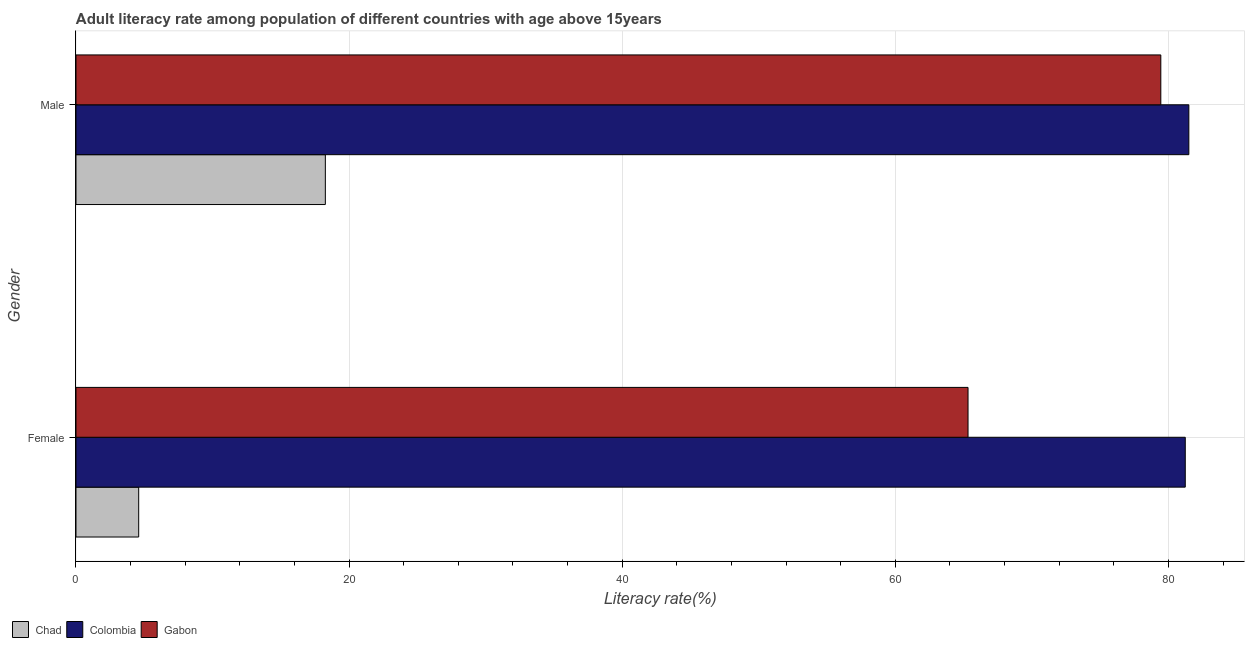How many different coloured bars are there?
Ensure brevity in your answer.  3. How many groups of bars are there?
Keep it short and to the point. 2. Are the number of bars on each tick of the Y-axis equal?
Provide a short and direct response. Yes. How many bars are there on the 2nd tick from the top?
Ensure brevity in your answer.  3. How many bars are there on the 1st tick from the bottom?
Your response must be concise. 3. What is the male adult literacy rate in Colombia?
Your answer should be compact. 81.5. Across all countries, what is the maximum male adult literacy rate?
Give a very brief answer. 81.5. Across all countries, what is the minimum male adult literacy rate?
Provide a short and direct response. 18.26. In which country was the male adult literacy rate minimum?
Your answer should be compact. Chad. What is the total male adult literacy rate in the graph?
Offer a very short reply. 179.2. What is the difference between the male adult literacy rate in Chad and that in Gabon?
Make the answer very short. -61.18. What is the difference between the female adult literacy rate in Colombia and the male adult literacy rate in Gabon?
Your response must be concise. 1.79. What is the average female adult literacy rate per country?
Provide a succinct answer. 50.38. What is the difference between the male adult literacy rate and female adult literacy rate in Colombia?
Your response must be concise. 0.26. In how many countries, is the male adult literacy rate greater than 8 %?
Make the answer very short. 3. What is the ratio of the male adult literacy rate in Gabon to that in Chad?
Provide a short and direct response. 4.35. Is the male adult literacy rate in Gabon less than that in Chad?
Provide a succinct answer. No. What does the 2nd bar from the top in Female represents?
Provide a succinct answer. Colombia. What does the 2nd bar from the bottom in Male represents?
Your answer should be very brief. Colombia. How many bars are there?
Ensure brevity in your answer.  6. What is the difference between two consecutive major ticks on the X-axis?
Your answer should be very brief. 20. Does the graph contain any zero values?
Provide a succinct answer. No. Where does the legend appear in the graph?
Your response must be concise. Bottom left. How many legend labels are there?
Provide a short and direct response. 3. What is the title of the graph?
Your answer should be very brief. Adult literacy rate among population of different countries with age above 15years. What is the label or title of the X-axis?
Offer a terse response. Literacy rate(%). What is the label or title of the Y-axis?
Make the answer very short. Gender. What is the Literacy rate(%) of Chad in Female?
Offer a very short reply. 4.59. What is the Literacy rate(%) of Colombia in Female?
Keep it short and to the point. 81.24. What is the Literacy rate(%) of Gabon in Female?
Your answer should be compact. 65.33. What is the Literacy rate(%) of Chad in Male?
Provide a succinct answer. 18.26. What is the Literacy rate(%) in Colombia in Male?
Make the answer very short. 81.5. What is the Literacy rate(%) in Gabon in Male?
Offer a terse response. 79.44. Across all Gender, what is the maximum Literacy rate(%) in Chad?
Offer a terse response. 18.26. Across all Gender, what is the maximum Literacy rate(%) of Colombia?
Keep it short and to the point. 81.5. Across all Gender, what is the maximum Literacy rate(%) in Gabon?
Make the answer very short. 79.44. Across all Gender, what is the minimum Literacy rate(%) in Chad?
Make the answer very short. 4.59. Across all Gender, what is the minimum Literacy rate(%) of Colombia?
Ensure brevity in your answer.  81.24. Across all Gender, what is the minimum Literacy rate(%) of Gabon?
Give a very brief answer. 65.33. What is the total Literacy rate(%) of Chad in the graph?
Give a very brief answer. 22.85. What is the total Literacy rate(%) of Colombia in the graph?
Your answer should be very brief. 162.73. What is the total Literacy rate(%) of Gabon in the graph?
Your response must be concise. 144.77. What is the difference between the Literacy rate(%) of Chad in Female and that in Male?
Give a very brief answer. -13.67. What is the difference between the Literacy rate(%) of Colombia in Female and that in Male?
Your response must be concise. -0.26. What is the difference between the Literacy rate(%) of Gabon in Female and that in Male?
Your response must be concise. -14.12. What is the difference between the Literacy rate(%) in Chad in Female and the Literacy rate(%) in Colombia in Male?
Provide a succinct answer. -76.91. What is the difference between the Literacy rate(%) in Chad in Female and the Literacy rate(%) in Gabon in Male?
Provide a succinct answer. -74.85. What is the difference between the Literacy rate(%) in Colombia in Female and the Literacy rate(%) in Gabon in Male?
Keep it short and to the point. 1.79. What is the average Literacy rate(%) of Chad per Gender?
Ensure brevity in your answer.  11.43. What is the average Literacy rate(%) of Colombia per Gender?
Keep it short and to the point. 81.37. What is the average Literacy rate(%) in Gabon per Gender?
Your answer should be compact. 72.39. What is the difference between the Literacy rate(%) in Chad and Literacy rate(%) in Colombia in Female?
Your answer should be compact. -76.64. What is the difference between the Literacy rate(%) of Chad and Literacy rate(%) of Gabon in Female?
Provide a succinct answer. -60.73. What is the difference between the Literacy rate(%) in Colombia and Literacy rate(%) in Gabon in Female?
Provide a short and direct response. 15.91. What is the difference between the Literacy rate(%) of Chad and Literacy rate(%) of Colombia in Male?
Offer a very short reply. -63.24. What is the difference between the Literacy rate(%) in Chad and Literacy rate(%) in Gabon in Male?
Provide a short and direct response. -61.18. What is the difference between the Literacy rate(%) of Colombia and Literacy rate(%) of Gabon in Male?
Your answer should be very brief. 2.05. What is the ratio of the Literacy rate(%) of Chad in Female to that in Male?
Offer a terse response. 0.25. What is the ratio of the Literacy rate(%) in Colombia in Female to that in Male?
Make the answer very short. 1. What is the ratio of the Literacy rate(%) in Gabon in Female to that in Male?
Keep it short and to the point. 0.82. What is the difference between the highest and the second highest Literacy rate(%) in Chad?
Provide a short and direct response. 13.67. What is the difference between the highest and the second highest Literacy rate(%) in Colombia?
Make the answer very short. 0.26. What is the difference between the highest and the second highest Literacy rate(%) of Gabon?
Offer a very short reply. 14.12. What is the difference between the highest and the lowest Literacy rate(%) in Chad?
Provide a short and direct response. 13.67. What is the difference between the highest and the lowest Literacy rate(%) in Colombia?
Keep it short and to the point. 0.26. What is the difference between the highest and the lowest Literacy rate(%) of Gabon?
Ensure brevity in your answer.  14.12. 